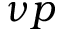<formula> <loc_0><loc_0><loc_500><loc_500>\nu p</formula> 